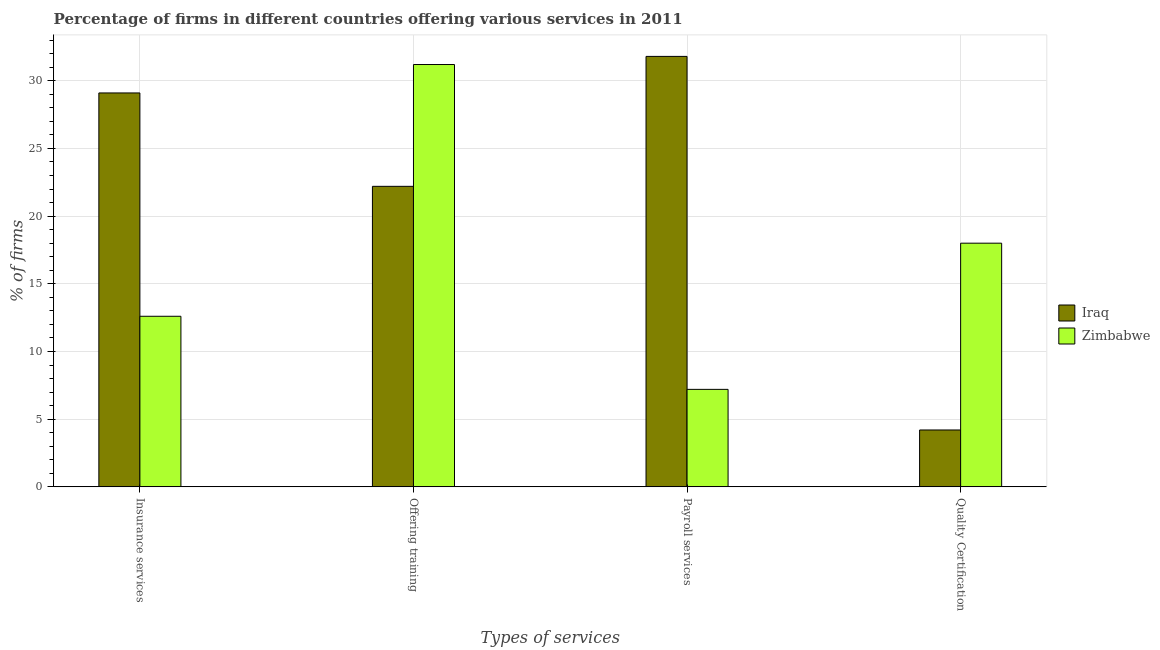How many different coloured bars are there?
Provide a short and direct response. 2. How many groups of bars are there?
Provide a succinct answer. 4. Are the number of bars per tick equal to the number of legend labels?
Your response must be concise. Yes. What is the label of the 3rd group of bars from the left?
Your answer should be compact. Payroll services. What is the percentage of firms offering payroll services in Iraq?
Provide a short and direct response. 31.8. Across all countries, what is the maximum percentage of firms offering insurance services?
Give a very brief answer. 29.1. Across all countries, what is the minimum percentage of firms offering training?
Give a very brief answer. 22.2. In which country was the percentage of firms offering quality certification maximum?
Provide a short and direct response. Zimbabwe. In which country was the percentage of firms offering insurance services minimum?
Provide a succinct answer. Zimbabwe. What is the total percentage of firms offering training in the graph?
Your response must be concise. 53.4. What is the difference between the percentage of firms offering training in Iraq and that in Zimbabwe?
Make the answer very short. -9. What is the difference between the percentage of firms offering insurance services in Zimbabwe and the percentage of firms offering payroll services in Iraq?
Your answer should be compact. -19.2. What is the difference between the percentage of firms offering training and percentage of firms offering payroll services in Zimbabwe?
Your answer should be compact. 24. What is the ratio of the percentage of firms offering insurance services in Iraq to that in Zimbabwe?
Offer a very short reply. 2.31. What is the difference between the highest and the lowest percentage of firms offering training?
Provide a short and direct response. 9. What does the 2nd bar from the left in Quality Certification represents?
Your response must be concise. Zimbabwe. What does the 2nd bar from the right in Offering training represents?
Offer a very short reply. Iraq. How many bars are there?
Your answer should be compact. 8. What is the difference between two consecutive major ticks on the Y-axis?
Keep it short and to the point. 5. Where does the legend appear in the graph?
Give a very brief answer. Center right. How many legend labels are there?
Offer a terse response. 2. How are the legend labels stacked?
Your response must be concise. Vertical. What is the title of the graph?
Make the answer very short. Percentage of firms in different countries offering various services in 2011. Does "New Caledonia" appear as one of the legend labels in the graph?
Your answer should be very brief. No. What is the label or title of the X-axis?
Ensure brevity in your answer.  Types of services. What is the label or title of the Y-axis?
Keep it short and to the point. % of firms. What is the % of firms in Iraq in Insurance services?
Your response must be concise. 29.1. What is the % of firms in Zimbabwe in Insurance services?
Keep it short and to the point. 12.6. What is the % of firms of Iraq in Offering training?
Provide a short and direct response. 22.2. What is the % of firms of Zimbabwe in Offering training?
Your response must be concise. 31.2. What is the % of firms of Iraq in Payroll services?
Your response must be concise. 31.8. What is the % of firms of Zimbabwe in Payroll services?
Offer a very short reply. 7.2. Across all Types of services, what is the maximum % of firms of Iraq?
Offer a terse response. 31.8. Across all Types of services, what is the maximum % of firms in Zimbabwe?
Keep it short and to the point. 31.2. Across all Types of services, what is the minimum % of firms in Zimbabwe?
Ensure brevity in your answer.  7.2. What is the total % of firms of Iraq in the graph?
Offer a terse response. 87.3. What is the total % of firms in Zimbabwe in the graph?
Ensure brevity in your answer.  69. What is the difference between the % of firms in Zimbabwe in Insurance services and that in Offering training?
Keep it short and to the point. -18.6. What is the difference between the % of firms in Iraq in Insurance services and that in Quality Certification?
Offer a terse response. 24.9. What is the difference between the % of firms in Iraq in Offering training and that in Payroll services?
Offer a very short reply. -9.6. What is the difference between the % of firms in Zimbabwe in Offering training and that in Payroll services?
Keep it short and to the point. 24. What is the difference between the % of firms in Iraq in Offering training and that in Quality Certification?
Keep it short and to the point. 18. What is the difference between the % of firms of Zimbabwe in Offering training and that in Quality Certification?
Give a very brief answer. 13.2. What is the difference between the % of firms of Iraq in Payroll services and that in Quality Certification?
Give a very brief answer. 27.6. What is the difference between the % of firms in Iraq in Insurance services and the % of firms in Zimbabwe in Offering training?
Make the answer very short. -2.1. What is the difference between the % of firms in Iraq in Insurance services and the % of firms in Zimbabwe in Payroll services?
Your answer should be very brief. 21.9. What is the difference between the % of firms in Iraq in Insurance services and the % of firms in Zimbabwe in Quality Certification?
Provide a short and direct response. 11.1. What is the difference between the % of firms in Iraq in Offering training and the % of firms in Zimbabwe in Payroll services?
Provide a succinct answer. 15. What is the average % of firms of Iraq per Types of services?
Make the answer very short. 21.82. What is the average % of firms in Zimbabwe per Types of services?
Ensure brevity in your answer.  17.25. What is the difference between the % of firms of Iraq and % of firms of Zimbabwe in Insurance services?
Give a very brief answer. 16.5. What is the difference between the % of firms in Iraq and % of firms in Zimbabwe in Payroll services?
Your response must be concise. 24.6. What is the ratio of the % of firms of Iraq in Insurance services to that in Offering training?
Provide a short and direct response. 1.31. What is the ratio of the % of firms in Zimbabwe in Insurance services to that in Offering training?
Ensure brevity in your answer.  0.4. What is the ratio of the % of firms in Iraq in Insurance services to that in Payroll services?
Ensure brevity in your answer.  0.92. What is the ratio of the % of firms in Iraq in Insurance services to that in Quality Certification?
Make the answer very short. 6.93. What is the ratio of the % of firms of Iraq in Offering training to that in Payroll services?
Provide a succinct answer. 0.7. What is the ratio of the % of firms in Zimbabwe in Offering training to that in Payroll services?
Offer a very short reply. 4.33. What is the ratio of the % of firms in Iraq in Offering training to that in Quality Certification?
Your answer should be compact. 5.29. What is the ratio of the % of firms of Zimbabwe in Offering training to that in Quality Certification?
Provide a short and direct response. 1.73. What is the ratio of the % of firms in Iraq in Payroll services to that in Quality Certification?
Offer a very short reply. 7.57. What is the ratio of the % of firms of Zimbabwe in Payroll services to that in Quality Certification?
Offer a terse response. 0.4. What is the difference between the highest and the second highest % of firms in Iraq?
Ensure brevity in your answer.  2.7. What is the difference between the highest and the lowest % of firms of Iraq?
Give a very brief answer. 27.6. What is the difference between the highest and the lowest % of firms of Zimbabwe?
Provide a succinct answer. 24. 